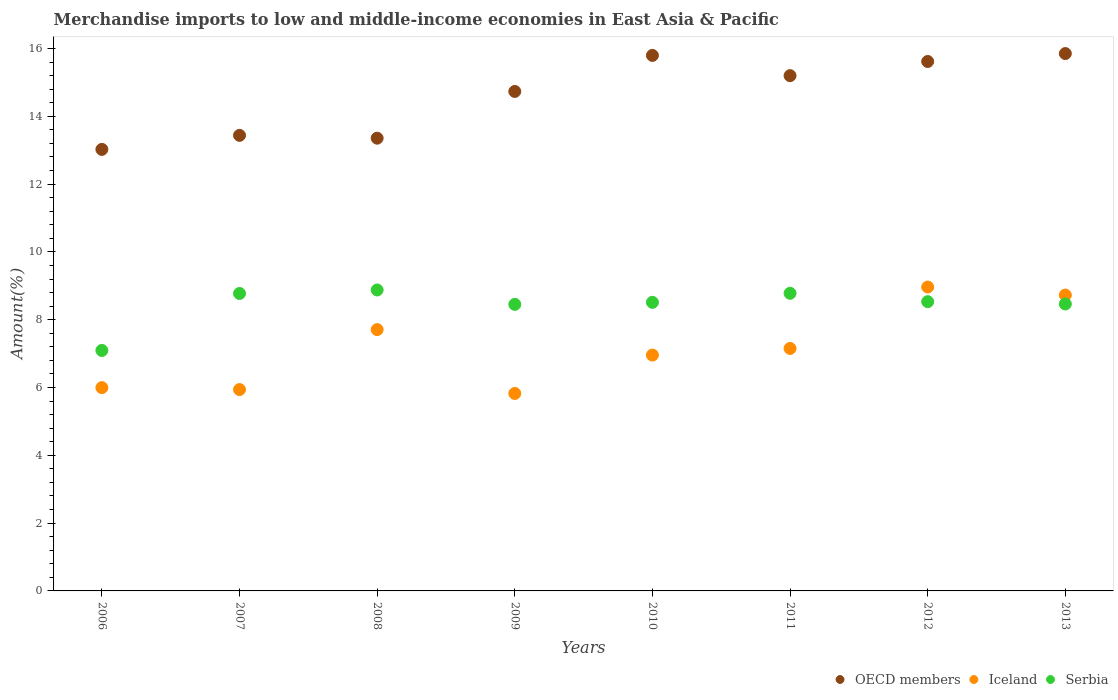Is the number of dotlines equal to the number of legend labels?
Keep it short and to the point. Yes. What is the percentage of amount earned from merchandise imports in OECD members in 2008?
Ensure brevity in your answer.  13.35. Across all years, what is the maximum percentage of amount earned from merchandise imports in Serbia?
Offer a very short reply. 8.88. Across all years, what is the minimum percentage of amount earned from merchandise imports in Serbia?
Provide a short and direct response. 7.09. In which year was the percentage of amount earned from merchandise imports in OECD members maximum?
Your response must be concise. 2013. What is the total percentage of amount earned from merchandise imports in OECD members in the graph?
Your answer should be very brief. 117.01. What is the difference between the percentage of amount earned from merchandise imports in OECD members in 2008 and that in 2012?
Your response must be concise. -2.26. What is the difference between the percentage of amount earned from merchandise imports in Iceland in 2006 and the percentage of amount earned from merchandise imports in Serbia in 2007?
Your answer should be very brief. -2.78. What is the average percentage of amount earned from merchandise imports in Iceland per year?
Provide a short and direct response. 7.16. In the year 2008, what is the difference between the percentage of amount earned from merchandise imports in OECD members and percentage of amount earned from merchandise imports in Serbia?
Your answer should be compact. 4.48. What is the ratio of the percentage of amount earned from merchandise imports in OECD members in 2008 to that in 2009?
Make the answer very short. 0.91. Is the percentage of amount earned from merchandise imports in Iceland in 2008 less than that in 2013?
Your answer should be compact. Yes. What is the difference between the highest and the second highest percentage of amount earned from merchandise imports in Serbia?
Keep it short and to the point. 0.1. What is the difference between the highest and the lowest percentage of amount earned from merchandise imports in Serbia?
Give a very brief answer. 1.78. In how many years, is the percentage of amount earned from merchandise imports in Iceland greater than the average percentage of amount earned from merchandise imports in Iceland taken over all years?
Your response must be concise. 3. Is it the case that in every year, the sum of the percentage of amount earned from merchandise imports in Iceland and percentage of amount earned from merchandise imports in OECD members  is greater than the percentage of amount earned from merchandise imports in Serbia?
Ensure brevity in your answer.  Yes. Does the percentage of amount earned from merchandise imports in Iceland monotonically increase over the years?
Offer a terse response. No. Is the percentage of amount earned from merchandise imports in Serbia strictly greater than the percentage of amount earned from merchandise imports in OECD members over the years?
Offer a terse response. No. Is the percentage of amount earned from merchandise imports in OECD members strictly less than the percentage of amount earned from merchandise imports in Iceland over the years?
Offer a terse response. No. How many years are there in the graph?
Provide a succinct answer. 8. Does the graph contain any zero values?
Offer a terse response. No. Where does the legend appear in the graph?
Make the answer very short. Bottom right. How are the legend labels stacked?
Offer a terse response. Horizontal. What is the title of the graph?
Your answer should be very brief. Merchandise imports to low and middle-income economies in East Asia & Pacific. Does "Guyana" appear as one of the legend labels in the graph?
Your answer should be very brief. No. What is the label or title of the Y-axis?
Your answer should be compact. Amount(%). What is the Amount(%) of OECD members in 2006?
Your answer should be compact. 13.02. What is the Amount(%) of Iceland in 2006?
Provide a short and direct response. 6. What is the Amount(%) in Serbia in 2006?
Keep it short and to the point. 7.09. What is the Amount(%) of OECD members in 2007?
Keep it short and to the point. 13.44. What is the Amount(%) of Iceland in 2007?
Keep it short and to the point. 5.94. What is the Amount(%) in Serbia in 2007?
Your response must be concise. 8.77. What is the Amount(%) of OECD members in 2008?
Ensure brevity in your answer.  13.35. What is the Amount(%) in Iceland in 2008?
Offer a terse response. 7.71. What is the Amount(%) in Serbia in 2008?
Your response must be concise. 8.88. What is the Amount(%) of OECD members in 2009?
Your answer should be compact. 14.73. What is the Amount(%) of Iceland in 2009?
Your answer should be very brief. 5.82. What is the Amount(%) of Serbia in 2009?
Your response must be concise. 8.45. What is the Amount(%) of OECD members in 2010?
Your response must be concise. 15.8. What is the Amount(%) in Iceland in 2010?
Your answer should be very brief. 6.96. What is the Amount(%) of Serbia in 2010?
Offer a very short reply. 8.51. What is the Amount(%) in OECD members in 2011?
Provide a succinct answer. 15.2. What is the Amount(%) in Iceland in 2011?
Ensure brevity in your answer.  7.15. What is the Amount(%) in Serbia in 2011?
Provide a succinct answer. 8.78. What is the Amount(%) in OECD members in 2012?
Your answer should be compact. 15.62. What is the Amount(%) of Iceland in 2012?
Give a very brief answer. 8.96. What is the Amount(%) in Serbia in 2012?
Give a very brief answer. 8.53. What is the Amount(%) in OECD members in 2013?
Provide a short and direct response. 15.85. What is the Amount(%) in Iceland in 2013?
Your response must be concise. 8.73. What is the Amount(%) in Serbia in 2013?
Provide a short and direct response. 8.46. Across all years, what is the maximum Amount(%) in OECD members?
Your answer should be very brief. 15.85. Across all years, what is the maximum Amount(%) in Iceland?
Offer a very short reply. 8.96. Across all years, what is the maximum Amount(%) of Serbia?
Provide a succinct answer. 8.88. Across all years, what is the minimum Amount(%) in OECD members?
Provide a succinct answer. 13.02. Across all years, what is the minimum Amount(%) in Iceland?
Give a very brief answer. 5.82. Across all years, what is the minimum Amount(%) in Serbia?
Ensure brevity in your answer.  7.09. What is the total Amount(%) in OECD members in the graph?
Make the answer very short. 117.01. What is the total Amount(%) in Iceland in the graph?
Keep it short and to the point. 57.26. What is the total Amount(%) of Serbia in the graph?
Your answer should be compact. 67.48. What is the difference between the Amount(%) in OECD members in 2006 and that in 2007?
Your answer should be compact. -0.41. What is the difference between the Amount(%) of Iceland in 2006 and that in 2007?
Provide a succinct answer. 0.06. What is the difference between the Amount(%) in Serbia in 2006 and that in 2007?
Provide a succinct answer. -1.68. What is the difference between the Amount(%) in OECD members in 2006 and that in 2008?
Provide a short and direct response. -0.33. What is the difference between the Amount(%) in Iceland in 2006 and that in 2008?
Provide a short and direct response. -1.71. What is the difference between the Amount(%) of Serbia in 2006 and that in 2008?
Provide a succinct answer. -1.78. What is the difference between the Amount(%) in OECD members in 2006 and that in 2009?
Provide a short and direct response. -1.71. What is the difference between the Amount(%) of Iceland in 2006 and that in 2009?
Ensure brevity in your answer.  0.17. What is the difference between the Amount(%) of Serbia in 2006 and that in 2009?
Offer a very short reply. -1.36. What is the difference between the Amount(%) of OECD members in 2006 and that in 2010?
Make the answer very short. -2.77. What is the difference between the Amount(%) in Iceland in 2006 and that in 2010?
Your answer should be very brief. -0.96. What is the difference between the Amount(%) in Serbia in 2006 and that in 2010?
Keep it short and to the point. -1.42. What is the difference between the Amount(%) of OECD members in 2006 and that in 2011?
Offer a terse response. -2.18. What is the difference between the Amount(%) in Iceland in 2006 and that in 2011?
Make the answer very short. -1.16. What is the difference between the Amount(%) of Serbia in 2006 and that in 2011?
Give a very brief answer. -1.69. What is the difference between the Amount(%) in OECD members in 2006 and that in 2012?
Your response must be concise. -2.59. What is the difference between the Amount(%) of Iceland in 2006 and that in 2012?
Provide a succinct answer. -2.97. What is the difference between the Amount(%) of Serbia in 2006 and that in 2012?
Your response must be concise. -1.44. What is the difference between the Amount(%) of OECD members in 2006 and that in 2013?
Your answer should be compact. -2.83. What is the difference between the Amount(%) of Iceland in 2006 and that in 2013?
Your response must be concise. -2.73. What is the difference between the Amount(%) of Serbia in 2006 and that in 2013?
Keep it short and to the point. -1.37. What is the difference between the Amount(%) of OECD members in 2007 and that in 2008?
Your answer should be compact. 0.08. What is the difference between the Amount(%) of Iceland in 2007 and that in 2008?
Offer a very short reply. -1.77. What is the difference between the Amount(%) in Serbia in 2007 and that in 2008?
Offer a very short reply. -0.1. What is the difference between the Amount(%) in OECD members in 2007 and that in 2009?
Make the answer very short. -1.29. What is the difference between the Amount(%) in Iceland in 2007 and that in 2009?
Your answer should be compact. 0.11. What is the difference between the Amount(%) of Serbia in 2007 and that in 2009?
Your answer should be compact. 0.32. What is the difference between the Amount(%) in OECD members in 2007 and that in 2010?
Your response must be concise. -2.36. What is the difference between the Amount(%) in Iceland in 2007 and that in 2010?
Provide a succinct answer. -1.02. What is the difference between the Amount(%) of Serbia in 2007 and that in 2010?
Your answer should be compact. 0.26. What is the difference between the Amount(%) in OECD members in 2007 and that in 2011?
Provide a short and direct response. -1.76. What is the difference between the Amount(%) in Iceland in 2007 and that in 2011?
Your answer should be very brief. -1.21. What is the difference between the Amount(%) of Serbia in 2007 and that in 2011?
Keep it short and to the point. -0.01. What is the difference between the Amount(%) in OECD members in 2007 and that in 2012?
Provide a short and direct response. -2.18. What is the difference between the Amount(%) of Iceland in 2007 and that in 2012?
Make the answer very short. -3.02. What is the difference between the Amount(%) in Serbia in 2007 and that in 2012?
Keep it short and to the point. 0.24. What is the difference between the Amount(%) in OECD members in 2007 and that in 2013?
Your response must be concise. -2.41. What is the difference between the Amount(%) in Iceland in 2007 and that in 2013?
Provide a succinct answer. -2.79. What is the difference between the Amount(%) in Serbia in 2007 and that in 2013?
Provide a succinct answer. 0.31. What is the difference between the Amount(%) of OECD members in 2008 and that in 2009?
Your answer should be very brief. -1.38. What is the difference between the Amount(%) in Iceland in 2008 and that in 2009?
Your answer should be compact. 1.88. What is the difference between the Amount(%) in Serbia in 2008 and that in 2009?
Provide a short and direct response. 0.43. What is the difference between the Amount(%) in OECD members in 2008 and that in 2010?
Your answer should be compact. -2.44. What is the difference between the Amount(%) in Iceland in 2008 and that in 2010?
Ensure brevity in your answer.  0.75. What is the difference between the Amount(%) in Serbia in 2008 and that in 2010?
Your answer should be compact. 0.36. What is the difference between the Amount(%) of OECD members in 2008 and that in 2011?
Provide a short and direct response. -1.84. What is the difference between the Amount(%) in Iceland in 2008 and that in 2011?
Your answer should be very brief. 0.56. What is the difference between the Amount(%) of Serbia in 2008 and that in 2011?
Keep it short and to the point. 0.1. What is the difference between the Amount(%) in OECD members in 2008 and that in 2012?
Your answer should be very brief. -2.26. What is the difference between the Amount(%) in Iceland in 2008 and that in 2012?
Your answer should be very brief. -1.26. What is the difference between the Amount(%) in Serbia in 2008 and that in 2012?
Provide a short and direct response. 0.35. What is the difference between the Amount(%) in OECD members in 2008 and that in 2013?
Make the answer very short. -2.5. What is the difference between the Amount(%) in Iceland in 2008 and that in 2013?
Your answer should be compact. -1.02. What is the difference between the Amount(%) of Serbia in 2008 and that in 2013?
Your answer should be very brief. 0.41. What is the difference between the Amount(%) in OECD members in 2009 and that in 2010?
Your answer should be compact. -1.06. What is the difference between the Amount(%) in Iceland in 2009 and that in 2010?
Your answer should be very brief. -1.13. What is the difference between the Amount(%) in Serbia in 2009 and that in 2010?
Provide a short and direct response. -0.06. What is the difference between the Amount(%) in OECD members in 2009 and that in 2011?
Your answer should be very brief. -0.47. What is the difference between the Amount(%) in Iceland in 2009 and that in 2011?
Your answer should be compact. -1.33. What is the difference between the Amount(%) in Serbia in 2009 and that in 2011?
Ensure brevity in your answer.  -0.33. What is the difference between the Amount(%) of OECD members in 2009 and that in 2012?
Provide a short and direct response. -0.88. What is the difference between the Amount(%) of Iceland in 2009 and that in 2012?
Ensure brevity in your answer.  -3.14. What is the difference between the Amount(%) of Serbia in 2009 and that in 2012?
Give a very brief answer. -0.08. What is the difference between the Amount(%) in OECD members in 2009 and that in 2013?
Offer a terse response. -1.12. What is the difference between the Amount(%) in Iceland in 2009 and that in 2013?
Offer a very short reply. -2.9. What is the difference between the Amount(%) in Serbia in 2009 and that in 2013?
Your answer should be compact. -0.01. What is the difference between the Amount(%) of OECD members in 2010 and that in 2011?
Keep it short and to the point. 0.6. What is the difference between the Amount(%) in Iceland in 2010 and that in 2011?
Your answer should be compact. -0.2. What is the difference between the Amount(%) of Serbia in 2010 and that in 2011?
Give a very brief answer. -0.27. What is the difference between the Amount(%) of OECD members in 2010 and that in 2012?
Offer a very short reply. 0.18. What is the difference between the Amount(%) of Iceland in 2010 and that in 2012?
Offer a very short reply. -2.01. What is the difference between the Amount(%) in Serbia in 2010 and that in 2012?
Give a very brief answer. -0.02. What is the difference between the Amount(%) of OECD members in 2010 and that in 2013?
Your response must be concise. -0.05. What is the difference between the Amount(%) in Iceland in 2010 and that in 2013?
Offer a terse response. -1.77. What is the difference between the Amount(%) in Serbia in 2010 and that in 2013?
Your response must be concise. 0.05. What is the difference between the Amount(%) of OECD members in 2011 and that in 2012?
Your answer should be very brief. -0.42. What is the difference between the Amount(%) of Iceland in 2011 and that in 2012?
Ensure brevity in your answer.  -1.81. What is the difference between the Amount(%) in Serbia in 2011 and that in 2012?
Provide a short and direct response. 0.25. What is the difference between the Amount(%) of OECD members in 2011 and that in 2013?
Provide a short and direct response. -0.65. What is the difference between the Amount(%) of Iceland in 2011 and that in 2013?
Offer a very short reply. -1.57. What is the difference between the Amount(%) in Serbia in 2011 and that in 2013?
Make the answer very short. 0.32. What is the difference between the Amount(%) of OECD members in 2012 and that in 2013?
Offer a terse response. -0.23. What is the difference between the Amount(%) in Iceland in 2012 and that in 2013?
Make the answer very short. 0.24. What is the difference between the Amount(%) in Serbia in 2012 and that in 2013?
Give a very brief answer. 0.07. What is the difference between the Amount(%) of OECD members in 2006 and the Amount(%) of Iceland in 2007?
Keep it short and to the point. 7.08. What is the difference between the Amount(%) in OECD members in 2006 and the Amount(%) in Serbia in 2007?
Provide a short and direct response. 4.25. What is the difference between the Amount(%) in Iceland in 2006 and the Amount(%) in Serbia in 2007?
Your answer should be compact. -2.78. What is the difference between the Amount(%) in OECD members in 2006 and the Amount(%) in Iceland in 2008?
Your answer should be very brief. 5.32. What is the difference between the Amount(%) of OECD members in 2006 and the Amount(%) of Serbia in 2008?
Offer a very short reply. 4.15. What is the difference between the Amount(%) in Iceland in 2006 and the Amount(%) in Serbia in 2008?
Offer a very short reply. -2.88. What is the difference between the Amount(%) in OECD members in 2006 and the Amount(%) in Iceland in 2009?
Ensure brevity in your answer.  7.2. What is the difference between the Amount(%) of OECD members in 2006 and the Amount(%) of Serbia in 2009?
Give a very brief answer. 4.57. What is the difference between the Amount(%) in Iceland in 2006 and the Amount(%) in Serbia in 2009?
Ensure brevity in your answer.  -2.46. What is the difference between the Amount(%) of OECD members in 2006 and the Amount(%) of Iceland in 2010?
Your answer should be compact. 6.07. What is the difference between the Amount(%) in OECD members in 2006 and the Amount(%) in Serbia in 2010?
Offer a very short reply. 4.51. What is the difference between the Amount(%) in Iceland in 2006 and the Amount(%) in Serbia in 2010?
Your answer should be compact. -2.52. What is the difference between the Amount(%) of OECD members in 2006 and the Amount(%) of Iceland in 2011?
Your answer should be compact. 5.87. What is the difference between the Amount(%) in OECD members in 2006 and the Amount(%) in Serbia in 2011?
Your response must be concise. 4.24. What is the difference between the Amount(%) of Iceland in 2006 and the Amount(%) of Serbia in 2011?
Ensure brevity in your answer.  -2.78. What is the difference between the Amount(%) in OECD members in 2006 and the Amount(%) in Iceland in 2012?
Your answer should be very brief. 4.06. What is the difference between the Amount(%) in OECD members in 2006 and the Amount(%) in Serbia in 2012?
Your answer should be compact. 4.49. What is the difference between the Amount(%) in Iceland in 2006 and the Amount(%) in Serbia in 2012?
Provide a short and direct response. -2.54. What is the difference between the Amount(%) in OECD members in 2006 and the Amount(%) in Iceland in 2013?
Offer a terse response. 4.3. What is the difference between the Amount(%) of OECD members in 2006 and the Amount(%) of Serbia in 2013?
Provide a succinct answer. 4.56. What is the difference between the Amount(%) of Iceland in 2006 and the Amount(%) of Serbia in 2013?
Your response must be concise. -2.47. What is the difference between the Amount(%) in OECD members in 2007 and the Amount(%) in Iceland in 2008?
Provide a short and direct response. 5.73. What is the difference between the Amount(%) in OECD members in 2007 and the Amount(%) in Serbia in 2008?
Make the answer very short. 4.56. What is the difference between the Amount(%) of Iceland in 2007 and the Amount(%) of Serbia in 2008?
Provide a succinct answer. -2.94. What is the difference between the Amount(%) of OECD members in 2007 and the Amount(%) of Iceland in 2009?
Keep it short and to the point. 7.61. What is the difference between the Amount(%) in OECD members in 2007 and the Amount(%) in Serbia in 2009?
Offer a very short reply. 4.99. What is the difference between the Amount(%) of Iceland in 2007 and the Amount(%) of Serbia in 2009?
Your answer should be compact. -2.51. What is the difference between the Amount(%) of OECD members in 2007 and the Amount(%) of Iceland in 2010?
Provide a short and direct response. 6.48. What is the difference between the Amount(%) in OECD members in 2007 and the Amount(%) in Serbia in 2010?
Your answer should be compact. 4.93. What is the difference between the Amount(%) of Iceland in 2007 and the Amount(%) of Serbia in 2010?
Provide a succinct answer. -2.57. What is the difference between the Amount(%) of OECD members in 2007 and the Amount(%) of Iceland in 2011?
Ensure brevity in your answer.  6.29. What is the difference between the Amount(%) in OECD members in 2007 and the Amount(%) in Serbia in 2011?
Make the answer very short. 4.66. What is the difference between the Amount(%) in Iceland in 2007 and the Amount(%) in Serbia in 2011?
Provide a short and direct response. -2.84. What is the difference between the Amount(%) in OECD members in 2007 and the Amount(%) in Iceland in 2012?
Your answer should be very brief. 4.47. What is the difference between the Amount(%) in OECD members in 2007 and the Amount(%) in Serbia in 2012?
Your answer should be compact. 4.91. What is the difference between the Amount(%) in Iceland in 2007 and the Amount(%) in Serbia in 2012?
Ensure brevity in your answer.  -2.59. What is the difference between the Amount(%) of OECD members in 2007 and the Amount(%) of Iceland in 2013?
Your response must be concise. 4.71. What is the difference between the Amount(%) of OECD members in 2007 and the Amount(%) of Serbia in 2013?
Your answer should be very brief. 4.97. What is the difference between the Amount(%) in Iceland in 2007 and the Amount(%) in Serbia in 2013?
Provide a succinct answer. -2.52. What is the difference between the Amount(%) of OECD members in 2008 and the Amount(%) of Iceland in 2009?
Make the answer very short. 7.53. What is the difference between the Amount(%) of OECD members in 2008 and the Amount(%) of Serbia in 2009?
Give a very brief answer. 4.9. What is the difference between the Amount(%) of Iceland in 2008 and the Amount(%) of Serbia in 2009?
Your answer should be very brief. -0.74. What is the difference between the Amount(%) in OECD members in 2008 and the Amount(%) in Iceland in 2010?
Provide a short and direct response. 6.4. What is the difference between the Amount(%) of OECD members in 2008 and the Amount(%) of Serbia in 2010?
Offer a terse response. 4.84. What is the difference between the Amount(%) of Iceland in 2008 and the Amount(%) of Serbia in 2010?
Your answer should be compact. -0.8. What is the difference between the Amount(%) in OECD members in 2008 and the Amount(%) in Iceland in 2011?
Give a very brief answer. 6.2. What is the difference between the Amount(%) of OECD members in 2008 and the Amount(%) of Serbia in 2011?
Provide a short and direct response. 4.58. What is the difference between the Amount(%) of Iceland in 2008 and the Amount(%) of Serbia in 2011?
Your answer should be compact. -1.07. What is the difference between the Amount(%) of OECD members in 2008 and the Amount(%) of Iceland in 2012?
Offer a very short reply. 4.39. What is the difference between the Amount(%) in OECD members in 2008 and the Amount(%) in Serbia in 2012?
Your answer should be very brief. 4.82. What is the difference between the Amount(%) in Iceland in 2008 and the Amount(%) in Serbia in 2012?
Your answer should be very brief. -0.82. What is the difference between the Amount(%) in OECD members in 2008 and the Amount(%) in Iceland in 2013?
Provide a short and direct response. 4.63. What is the difference between the Amount(%) in OECD members in 2008 and the Amount(%) in Serbia in 2013?
Offer a terse response. 4.89. What is the difference between the Amount(%) in Iceland in 2008 and the Amount(%) in Serbia in 2013?
Your response must be concise. -0.76. What is the difference between the Amount(%) in OECD members in 2009 and the Amount(%) in Iceland in 2010?
Provide a short and direct response. 7.78. What is the difference between the Amount(%) of OECD members in 2009 and the Amount(%) of Serbia in 2010?
Give a very brief answer. 6.22. What is the difference between the Amount(%) of Iceland in 2009 and the Amount(%) of Serbia in 2010?
Keep it short and to the point. -2.69. What is the difference between the Amount(%) in OECD members in 2009 and the Amount(%) in Iceland in 2011?
Make the answer very short. 7.58. What is the difference between the Amount(%) in OECD members in 2009 and the Amount(%) in Serbia in 2011?
Keep it short and to the point. 5.95. What is the difference between the Amount(%) in Iceland in 2009 and the Amount(%) in Serbia in 2011?
Offer a very short reply. -2.95. What is the difference between the Amount(%) in OECD members in 2009 and the Amount(%) in Iceland in 2012?
Keep it short and to the point. 5.77. What is the difference between the Amount(%) in OECD members in 2009 and the Amount(%) in Serbia in 2012?
Ensure brevity in your answer.  6.2. What is the difference between the Amount(%) in Iceland in 2009 and the Amount(%) in Serbia in 2012?
Ensure brevity in your answer.  -2.71. What is the difference between the Amount(%) of OECD members in 2009 and the Amount(%) of Iceland in 2013?
Offer a very short reply. 6.01. What is the difference between the Amount(%) in OECD members in 2009 and the Amount(%) in Serbia in 2013?
Your response must be concise. 6.27. What is the difference between the Amount(%) in Iceland in 2009 and the Amount(%) in Serbia in 2013?
Make the answer very short. -2.64. What is the difference between the Amount(%) in OECD members in 2010 and the Amount(%) in Iceland in 2011?
Provide a short and direct response. 8.64. What is the difference between the Amount(%) of OECD members in 2010 and the Amount(%) of Serbia in 2011?
Your answer should be very brief. 7.02. What is the difference between the Amount(%) in Iceland in 2010 and the Amount(%) in Serbia in 2011?
Your answer should be compact. -1.82. What is the difference between the Amount(%) in OECD members in 2010 and the Amount(%) in Iceland in 2012?
Give a very brief answer. 6.83. What is the difference between the Amount(%) in OECD members in 2010 and the Amount(%) in Serbia in 2012?
Your response must be concise. 7.26. What is the difference between the Amount(%) in Iceland in 2010 and the Amount(%) in Serbia in 2012?
Provide a succinct answer. -1.57. What is the difference between the Amount(%) in OECD members in 2010 and the Amount(%) in Iceland in 2013?
Your response must be concise. 7.07. What is the difference between the Amount(%) in OECD members in 2010 and the Amount(%) in Serbia in 2013?
Provide a short and direct response. 7.33. What is the difference between the Amount(%) in Iceland in 2010 and the Amount(%) in Serbia in 2013?
Keep it short and to the point. -1.51. What is the difference between the Amount(%) in OECD members in 2011 and the Amount(%) in Iceland in 2012?
Your response must be concise. 6.23. What is the difference between the Amount(%) of OECD members in 2011 and the Amount(%) of Serbia in 2012?
Provide a succinct answer. 6.67. What is the difference between the Amount(%) of Iceland in 2011 and the Amount(%) of Serbia in 2012?
Give a very brief answer. -1.38. What is the difference between the Amount(%) in OECD members in 2011 and the Amount(%) in Iceland in 2013?
Keep it short and to the point. 6.47. What is the difference between the Amount(%) of OECD members in 2011 and the Amount(%) of Serbia in 2013?
Your answer should be compact. 6.73. What is the difference between the Amount(%) of Iceland in 2011 and the Amount(%) of Serbia in 2013?
Provide a succinct answer. -1.31. What is the difference between the Amount(%) of OECD members in 2012 and the Amount(%) of Iceland in 2013?
Give a very brief answer. 6.89. What is the difference between the Amount(%) of OECD members in 2012 and the Amount(%) of Serbia in 2013?
Offer a terse response. 7.15. What is the difference between the Amount(%) in Iceland in 2012 and the Amount(%) in Serbia in 2013?
Ensure brevity in your answer.  0.5. What is the average Amount(%) of OECD members per year?
Give a very brief answer. 14.63. What is the average Amount(%) of Iceland per year?
Keep it short and to the point. 7.16. What is the average Amount(%) of Serbia per year?
Offer a terse response. 8.44. In the year 2006, what is the difference between the Amount(%) in OECD members and Amount(%) in Iceland?
Your answer should be compact. 7.03. In the year 2006, what is the difference between the Amount(%) in OECD members and Amount(%) in Serbia?
Make the answer very short. 5.93. In the year 2006, what is the difference between the Amount(%) in Iceland and Amount(%) in Serbia?
Your response must be concise. -1.1. In the year 2007, what is the difference between the Amount(%) of OECD members and Amount(%) of Iceland?
Your answer should be very brief. 7.5. In the year 2007, what is the difference between the Amount(%) of OECD members and Amount(%) of Serbia?
Offer a very short reply. 4.66. In the year 2007, what is the difference between the Amount(%) of Iceland and Amount(%) of Serbia?
Offer a terse response. -2.83. In the year 2008, what is the difference between the Amount(%) of OECD members and Amount(%) of Iceland?
Your answer should be very brief. 5.65. In the year 2008, what is the difference between the Amount(%) of OECD members and Amount(%) of Serbia?
Make the answer very short. 4.48. In the year 2008, what is the difference between the Amount(%) in Iceland and Amount(%) in Serbia?
Provide a succinct answer. -1.17. In the year 2009, what is the difference between the Amount(%) in OECD members and Amount(%) in Iceland?
Offer a terse response. 8.91. In the year 2009, what is the difference between the Amount(%) of OECD members and Amount(%) of Serbia?
Your response must be concise. 6.28. In the year 2009, what is the difference between the Amount(%) of Iceland and Amount(%) of Serbia?
Provide a short and direct response. -2.63. In the year 2010, what is the difference between the Amount(%) in OECD members and Amount(%) in Iceland?
Give a very brief answer. 8.84. In the year 2010, what is the difference between the Amount(%) in OECD members and Amount(%) in Serbia?
Ensure brevity in your answer.  7.28. In the year 2010, what is the difference between the Amount(%) of Iceland and Amount(%) of Serbia?
Keep it short and to the point. -1.56. In the year 2011, what is the difference between the Amount(%) in OECD members and Amount(%) in Iceland?
Offer a terse response. 8.05. In the year 2011, what is the difference between the Amount(%) in OECD members and Amount(%) in Serbia?
Ensure brevity in your answer.  6.42. In the year 2011, what is the difference between the Amount(%) in Iceland and Amount(%) in Serbia?
Your answer should be very brief. -1.63. In the year 2012, what is the difference between the Amount(%) of OECD members and Amount(%) of Iceland?
Offer a terse response. 6.65. In the year 2012, what is the difference between the Amount(%) of OECD members and Amount(%) of Serbia?
Keep it short and to the point. 7.08. In the year 2012, what is the difference between the Amount(%) in Iceland and Amount(%) in Serbia?
Ensure brevity in your answer.  0.43. In the year 2013, what is the difference between the Amount(%) in OECD members and Amount(%) in Iceland?
Give a very brief answer. 7.12. In the year 2013, what is the difference between the Amount(%) of OECD members and Amount(%) of Serbia?
Provide a short and direct response. 7.39. In the year 2013, what is the difference between the Amount(%) in Iceland and Amount(%) in Serbia?
Your answer should be compact. 0.26. What is the ratio of the Amount(%) of OECD members in 2006 to that in 2007?
Provide a short and direct response. 0.97. What is the ratio of the Amount(%) of Iceland in 2006 to that in 2007?
Make the answer very short. 1.01. What is the ratio of the Amount(%) in Serbia in 2006 to that in 2007?
Provide a succinct answer. 0.81. What is the ratio of the Amount(%) of OECD members in 2006 to that in 2008?
Make the answer very short. 0.98. What is the ratio of the Amount(%) in Iceland in 2006 to that in 2008?
Your answer should be compact. 0.78. What is the ratio of the Amount(%) of Serbia in 2006 to that in 2008?
Provide a succinct answer. 0.8. What is the ratio of the Amount(%) of OECD members in 2006 to that in 2009?
Offer a terse response. 0.88. What is the ratio of the Amount(%) in Iceland in 2006 to that in 2009?
Your answer should be compact. 1.03. What is the ratio of the Amount(%) in Serbia in 2006 to that in 2009?
Your answer should be very brief. 0.84. What is the ratio of the Amount(%) of OECD members in 2006 to that in 2010?
Offer a terse response. 0.82. What is the ratio of the Amount(%) in Iceland in 2006 to that in 2010?
Your answer should be very brief. 0.86. What is the ratio of the Amount(%) in Serbia in 2006 to that in 2010?
Ensure brevity in your answer.  0.83. What is the ratio of the Amount(%) of OECD members in 2006 to that in 2011?
Provide a succinct answer. 0.86. What is the ratio of the Amount(%) of Iceland in 2006 to that in 2011?
Your answer should be very brief. 0.84. What is the ratio of the Amount(%) in Serbia in 2006 to that in 2011?
Make the answer very short. 0.81. What is the ratio of the Amount(%) of OECD members in 2006 to that in 2012?
Give a very brief answer. 0.83. What is the ratio of the Amount(%) of Iceland in 2006 to that in 2012?
Your answer should be compact. 0.67. What is the ratio of the Amount(%) of Serbia in 2006 to that in 2012?
Offer a very short reply. 0.83. What is the ratio of the Amount(%) of OECD members in 2006 to that in 2013?
Offer a very short reply. 0.82. What is the ratio of the Amount(%) of Iceland in 2006 to that in 2013?
Provide a succinct answer. 0.69. What is the ratio of the Amount(%) in Serbia in 2006 to that in 2013?
Give a very brief answer. 0.84. What is the ratio of the Amount(%) of OECD members in 2007 to that in 2008?
Make the answer very short. 1.01. What is the ratio of the Amount(%) in Iceland in 2007 to that in 2008?
Provide a succinct answer. 0.77. What is the ratio of the Amount(%) in Serbia in 2007 to that in 2008?
Give a very brief answer. 0.99. What is the ratio of the Amount(%) in OECD members in 2007 to that in 2009?
Your response must be concise. 0.91. What is the ratio of the Amount(%) of Iceland in 2007 to that in 2009?
Your answer should be compact. 1.02. What is the ratio of the Amount(%) of Serbia in 2007 to that in 2009?
Your answer should be very brief. 1.04. What is the ratio of the Amount(%) of OECD members in 2007 to that in 2010?
Make the answer very short. 0.85. What is the ratio of the Amount(%) in Iceland in 2007 to that in 2010?
Your answer should be compact. 0.85. What is the ratio of the Amount(%) of Serbia in 2007 to that in 2010?
Your answer should be compact. 1.03. What is the ratio of the Amount(%) in OECD members in 2007 to that in 2011?
Provide a short and direct response. 0.88. What is the ratio of the Amount(%) of Iceland in 2007 to that in 2011?
Provide a succinct answer. 0.83. What is the ratio of the Amount(%) in OECD members in 2007 to that in 2012?
Provide a short and direct response. 0.86. What is the ratio of the Amount(%) of Iceland in 2007 to that in 2012?
Offer a terse response. 0.66. What is the ratio of the Amount(%) of Serbia in 2007 to that in 2012?
Your response must be concise. 1.03. What is the ratio of the Amount(%) in OECD members in 2007 to that in 2013?
Your answer should be very brief. 0.85. What is the ratio of the Amount(%) in Iceland in 2007 to that in 2013?
Offer a very short reply. 0.68. What is the ratio of the Amount(%) of Serbia in 2007 to that in 2013?
Provide a short and direct response. 1.04. What is the ratio of the Amount(%) of OECD members in 2008 to that in 2009?
Your answer should be very brief. 0.91. What is the ratio of the Amount(%) of Iceland in 2008 to that in 2009?
Make the answer very short. 1.32. What is the ratio of the Amount(%) of Serbia in 2008 to that in 2009?
Provide a succinct answer. 1.05. What is the ratio of the Amount(%) in OECD members in 2008 to that in 2010?
Your answer should be compact. 0.85. What is the ratio of the Amount(%) in Iceland in 2008 to that in 2010?
Ensure brevity in your answer.  1.11. What is the ratio of the Amount(%) of Serbia in 2008 to that in 2010?
Your answer should be very brief. 1.04. What is the ratio of the Amount(%) in OECD members in 2008 to that in 2011?
Offer a very short reply. 0.88. What is the ratio of the Amount(%) in Iceland in 2008 to that in 2011?
Your answer should be very brief. 1.08. What is the ratio of the Amount(%) in Serbia in 2008 to that in 2011?
Your answer should be very brief. 1.01. What is the ratio of the Amount(%) in OECD members in 2008 to that in 2012?
Your response must be concise. 0.86. What is the ratio of the Amount(%) of Iceland in 2008 to that in 2012?
Offer a very short reply. 0.86. What is the ratio of the Amount(%) of Serbia in 2008 to that in 2012?
Ensure brevity in your answer.  1.04. What is the ratio of the Amount(%) of OECD members in 2008 to that in 2013?
Your response must be concise. 0.84. What is the ratio of the Amount(%) of Iceland in 2008 to that in 2013?
Your answer should be compact. 0.88. What is the ratio of the Amount(%) of Serbia in 2008 to that in 2013?
Offer a terse response. 1.05. What is the ratio of the Amount(%) of OECD members in 2009 to that in 2010?
Your answer should be very brief. 0.93. What is the ratio of the Amount(%) in Iceland in 2009 to that in 2010?
Give a very brief answer. 0.84. What is the ratio of the Amount(%) in OECD members in 2009 to that in 2011?
Give a very brief answer. 0.97. What is the ratio of the Amount(%) of Iceland in 2009 to that in 2011?
Keep it short and to the point. 0.81. What is the ratio of the Amount(%) in Serbia in 2009 to that in 2011?
Give a very brief answer. 0.96. What is the ratio of the Amount(%) in OECD members in 2009 to that in 2012?
Ensure brevity in your answer.  0.94. What is the ratio of the Amount(%) in Iceland in 2009 to that in 2012?
Your answer should be compact. 0.65. What is the ratio of the Amount(%) in Serbia in 2009 to that in 2012?
Provide a short and direct response. 0.99. What is the ratio of the Amount(%) of OECD members in 2009 to that in 2013?
Make the answer very short. 0.93. What is the ratio of the Amount(%) of Iceland in 2009 to that in 2013?
Ensure brevity in your answer.  0.67. What is the ratio of the Amount(%) of Serbia in 2009 to that in 2013?
Offer a terse response. 1. What is the ratio of the Amount(%) in OECD members in 2010 to that in 2011?
Your answer should be very brief. 1.04. What is the ratio of the Amount(%) in Iceland in 2010 to that in 2011?
Provide a succinct answer. 0.97. What is the ratio of the Amount(%) in Serbia in 2010 to that in 2011?
Offer a very short reply. 0.97. What is the ratio of the Amount(%) of OECD members in 2010 to that in 2012?
Offer a very short reply. 1.01. What is the ratio of the Amount(%) of Iceland in 2010 to that in 2012?
Keep it short and to the point. 0.78. What is the ratio of the Amount(%) in Serbia in 2010 to that in 2012?
Make the answer very short. 1. What is the ratio of the Amount(%) of Iceland in 2010 to that in 2013?
Provide a short and direct response. 0.8. What is the ratio of the Amount(%) of Serbia in 2010 to that in 2013?
Provide a short and direct response. 1.01. What is the ratio of the Amount(%) in OECD members in 2011 to that in 2012?
Ensure brevity in your answer.  0.97. What is the ratio of the Amount(%) of Iceland in 2011 to that in 2012?
Offer a terse response. 0.8. What is the ratio of the Amount(%) of OECD members in 2011 to that in 2013?
Provide a short and direct response. 0.96. What is the ratio of the Amount(%) of Iceland in 2011 to that in 2013?
Offer a terse response. 0.82. What is the ratio of the Amount(%) in Serbia in 2011 to that in 2013?
Offer a very short reply. 1.04. What is the ratio of the Amount(%) of OECD members in 2012 to that in 2013?
Offer a very short reply. 0.99. What is the ratio of the Amount(%) in Iceland in 2012 to that in 2013?
Your answer should be very brief. 1.03. What is the ratio of the Amount(%) of Serbia in 2012 to that in 2013?
Offer a very short reply. 1.01. What is the difference between the highest and the second highest Amount(%) of OECD members?
Make the answer very short. 0.05. What is the difference between the highest and the second highest Amount(%) in Iceland?
Your answer should be compact. 0.24. What is the difference between the highest and the second highest Amount(%) of Serbia?
Provide a short and direct response. 0.1. What is the difference between the highest and the lowest Amount(%) in OECD members?
Your answer should be compact. 2.83. What is the difference between the highest and the lowest Amount(%) in Iceland?
Keep it short and to the point. 3.14. What is the difference between the highest and the lowest Amount(%) in Serbia?
Offer a very short reply. 1.78. 